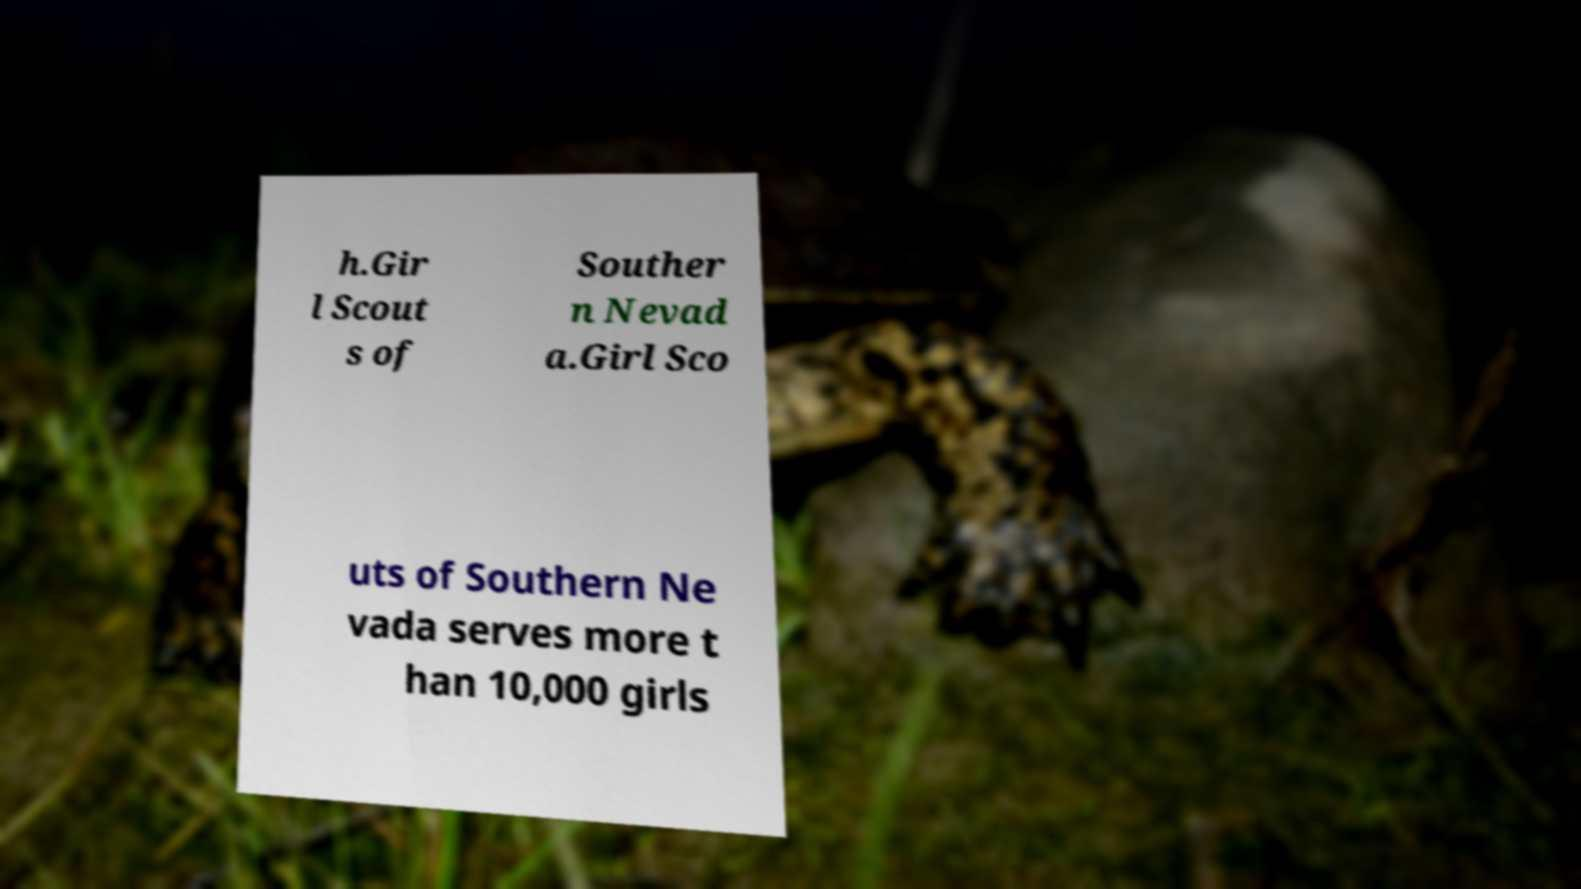What messages or text are displayed in this image? I need them in a readable, typed format. h.Gir l Scout s of Souther n Nevad a.Girl Sco uts of Southern Ne vada serves more t han 10,000 girls 